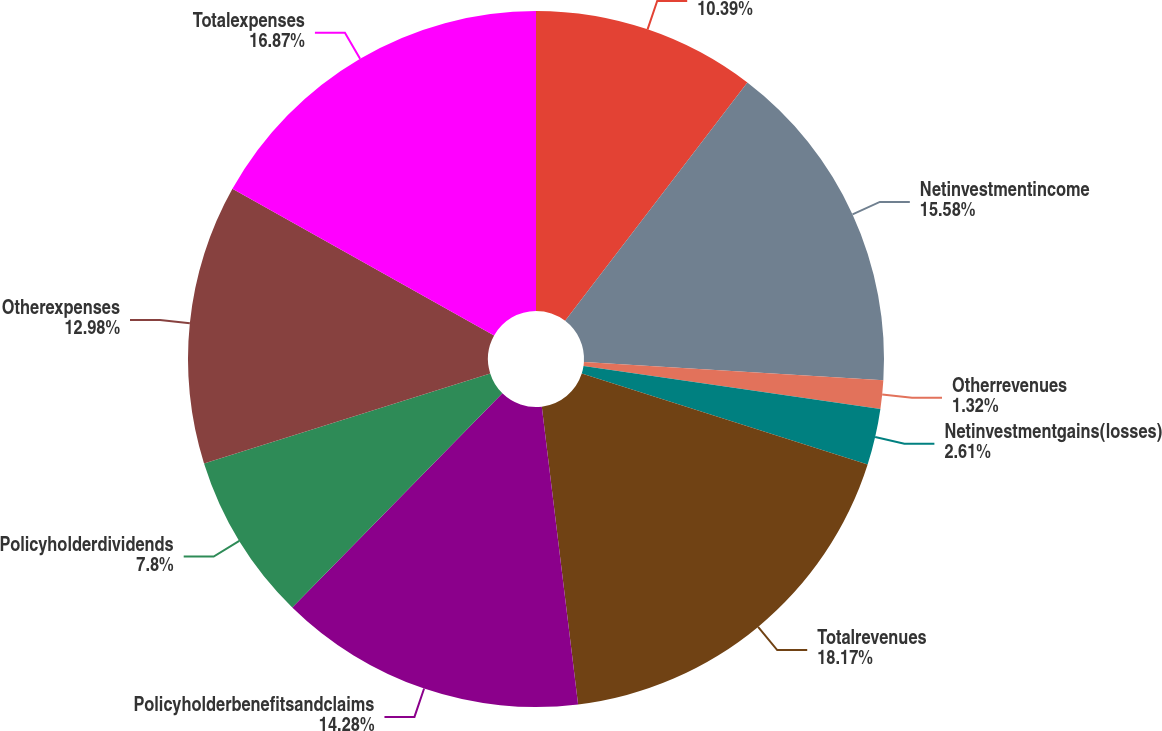Convert chart. <chart><loc_0><loc_0><loc_500><loc_500><pie_chart><ecel><fcel>Netinvestmentincome<fcel>Otherrevenues<fcel>Netinvestmentgains(losses)<fcel>Totalrevenues<fcel>Policyholderbenefitsandclaims<fcel>Policyholderdividends<fcel>Otherexpenses<fcel>Totalexpenses<nl><fcel>10.39%<fcel>15.58%<fcel>1.32%<fcel>2.61%<fcel>18.17%<fcel>14.28%<fcel>7.8%<fcel>12.98%<fcel>16.87%<nl></chart> 